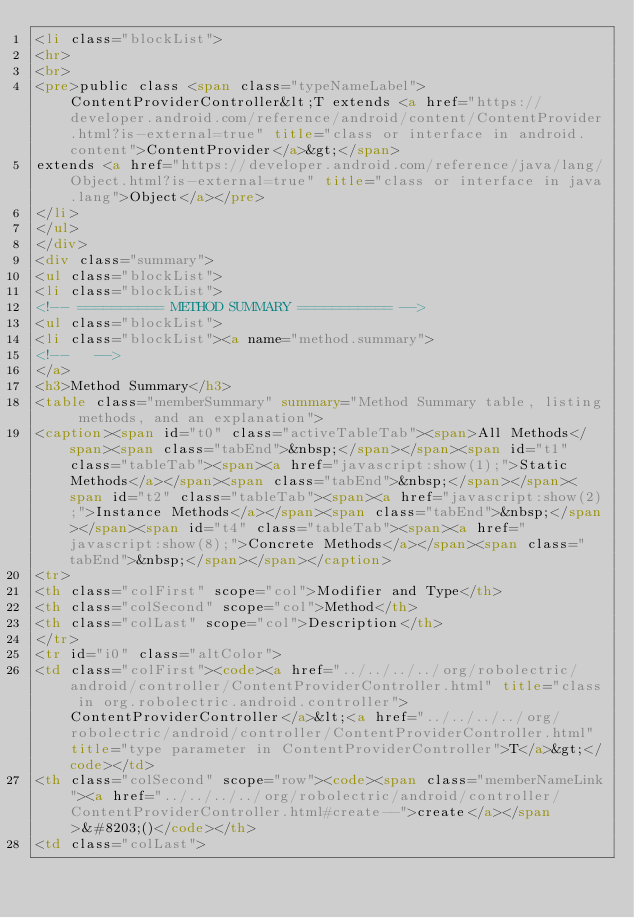<code> <loc_0><loc_0><loc_500><loc_500><_HTML_><li class="blockList">
<hr>
<br>
<pre>public class <span class="typeNameLabel">ContentProviderController&lt;T extends <a href="https://developer.android.com/reference/android/content/ContentProvider.html?is-external=true" title="class or interface in android.content">ContentProvider</a>&gt;</span>
extends <a href="https://developer.android.com/reference/java/lang/Object.html?is-external=true" title="class or interface in java.lang">Object</a></pre>
</li>
</ul>
</div>
<div class="summary">
<ul class="blockList">
<li class="blockList">
<!-- ========== METHOD SUMMARY =========== -->
<ul class="blockList">
<li class="blockList"><a name="method.summary">
<!--   -->
</a>
<h3>Method Summary</h3>
<table class="memberSummary" summary="Method Summary table, listing methods, and an explanation">
<caption><span id="t0" class="activeTableTab"><span>All Methods</span><span class="tabEnd">&nbsp;</span></span><span id="t1" class="tableTab"><span><a href="javascript:show(1);">Static Methods</a></span><span class="tabEnd">&nbsp;</span></span><span id="t2" class="tableTab"><span><a href="javascript:show(2);">Instance Methods</a></span><span class="tabEnd">&nbsp;</span></span><span id="t4" class="tableTab"><span><a href="javascript:show(8);">Concrete Methods</a></span><span class="tabEnd">&nbsp;</span></span></caption>
<tr>
<th class="colFirst" scope="col">Modifier and Type</th>
<th class="colSecond" scope="col">Method</th>
<th class="colLast" scope="col">Description</th>
</tr>
<tr id="i0" class="altColor">
<td class="colFirst"><code><a href="../../../../org/robolectric/android/controller/ContentProviderController.html" title="class in org.robolectric.android.controller">ContentProviderController</a>&lt;<a href="../../../../org/robolectric/android/controller/ContentProviderController.html" title="type parameter in ContentProviderController">T</a>&gt;</code></td>
<th class="colSecond" scope="row"><code><span class="memberNameLink"><a href="../../../../org/robolectric/android/controller/ContentProviderController.html#create--">create</a></span>&#8203;()</code></th>
<td class="colLast"></code> 